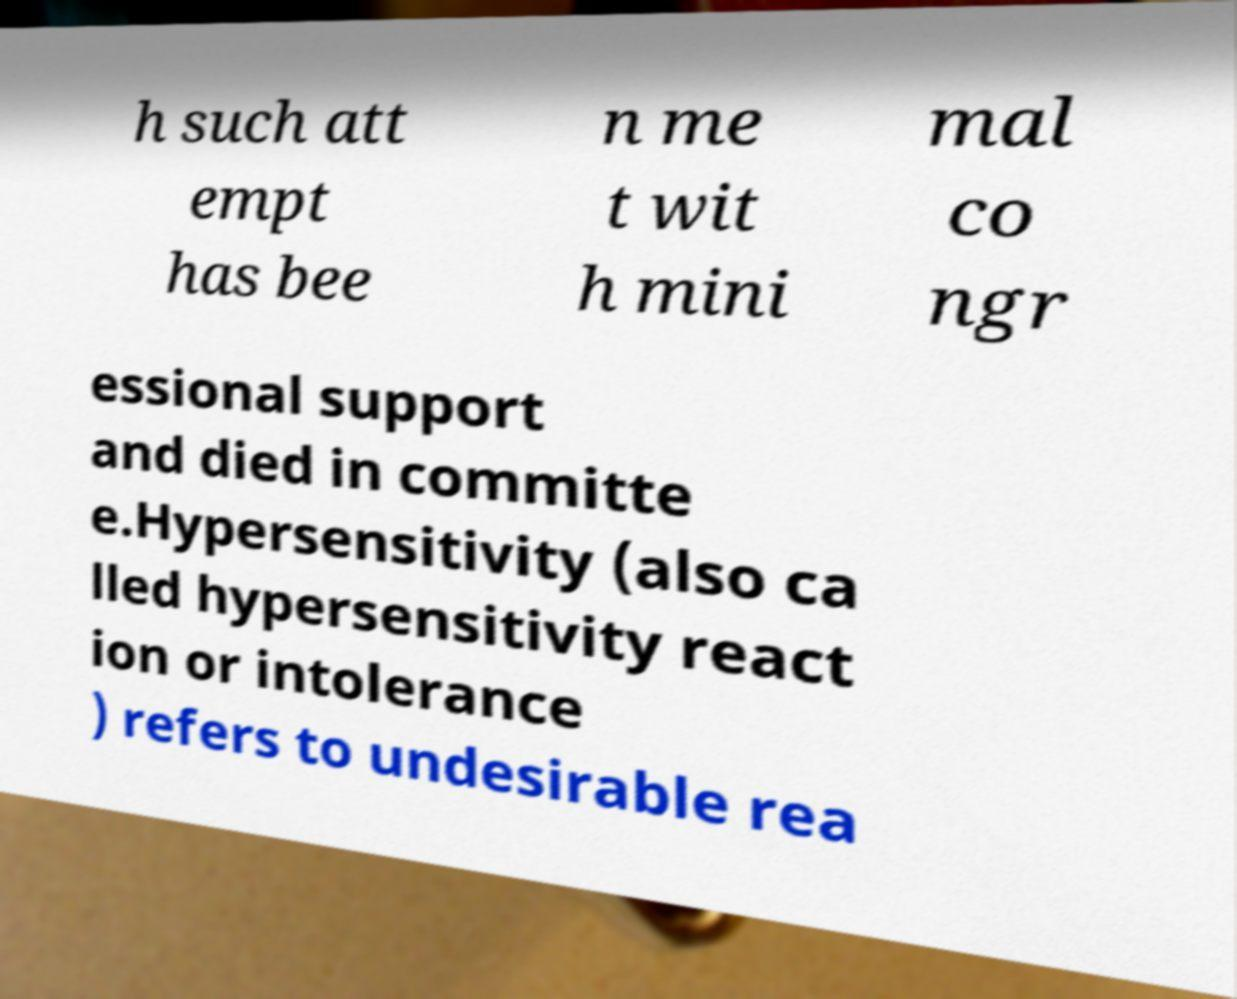I need the written content from this picture converted into text. Can you do that? h such att empt has bee n me t wit h mini mal co ngr essional support and died in committe e.Hypersensitivity (also ca lled hypersensitivity react ion or intolerance ) refers to undesirable rea 